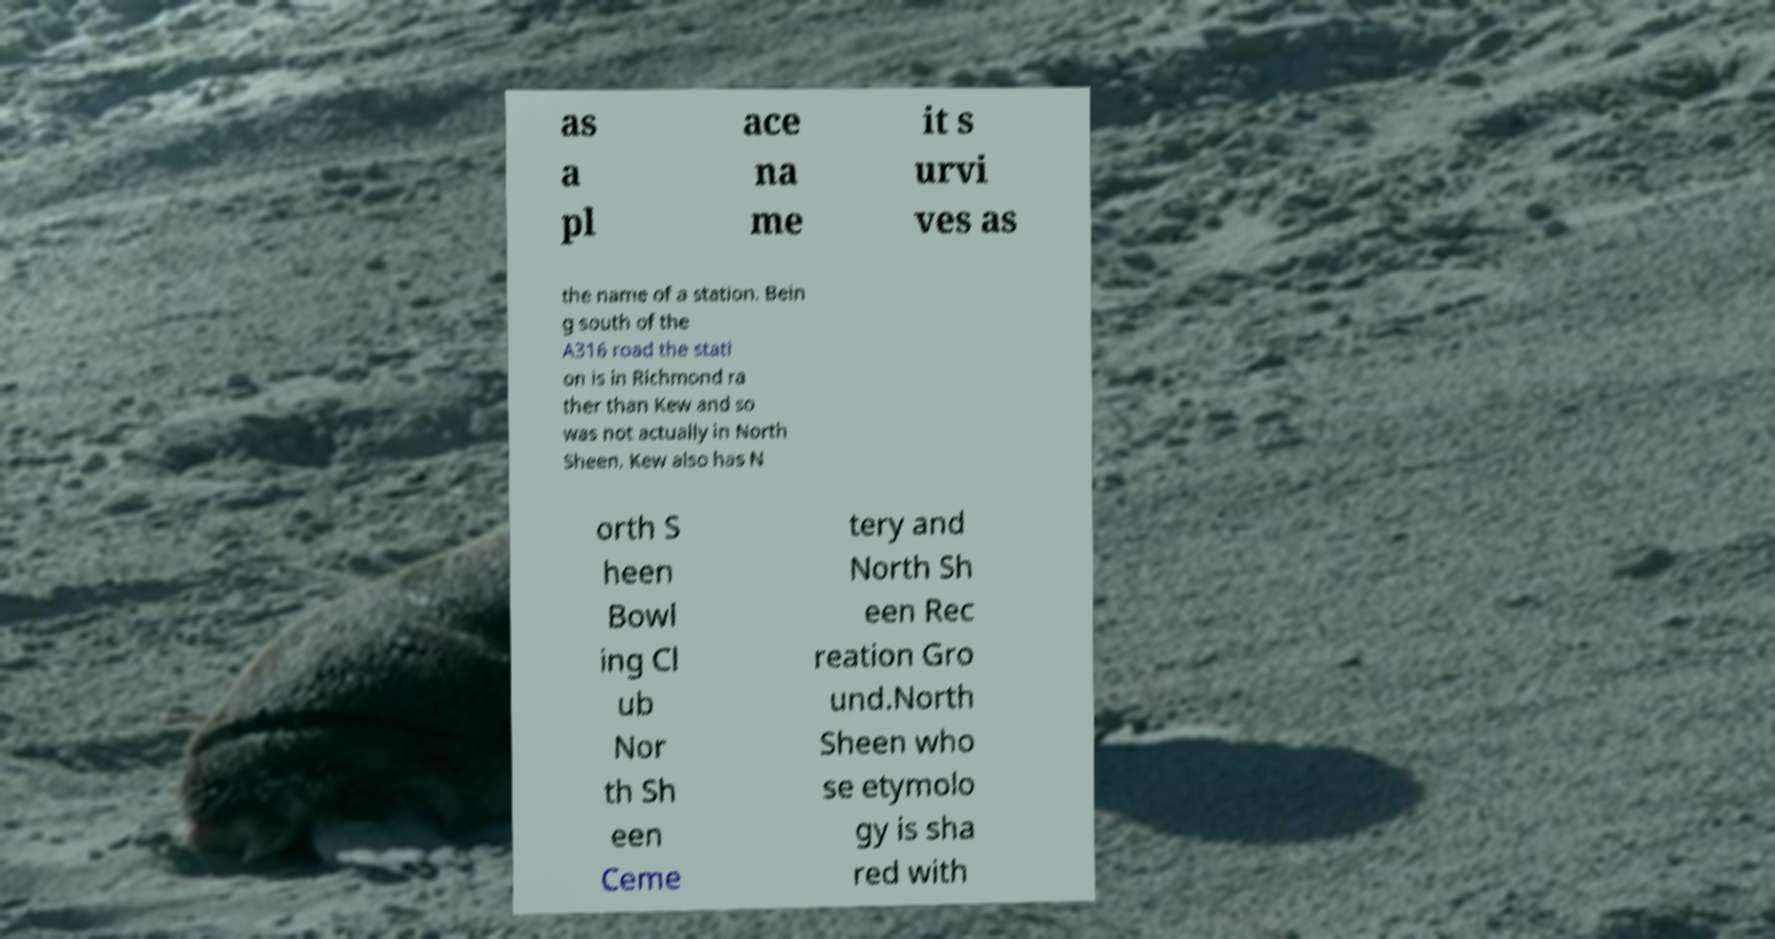Please read and relay the text visible in this image. What does it say? as a pl ace na me it s urvi ves as the name of a station. Bein g south of the A316 road the stati on is in Richmond ra ther than Kew and so was not actually in North Sheen. Kew also has N orth S heen Bowl ing Cl ub Nor th Sh een Ceme tery and North Sh een Rec reation Gro und.North Sheen who se etymolo gy is sha red with 